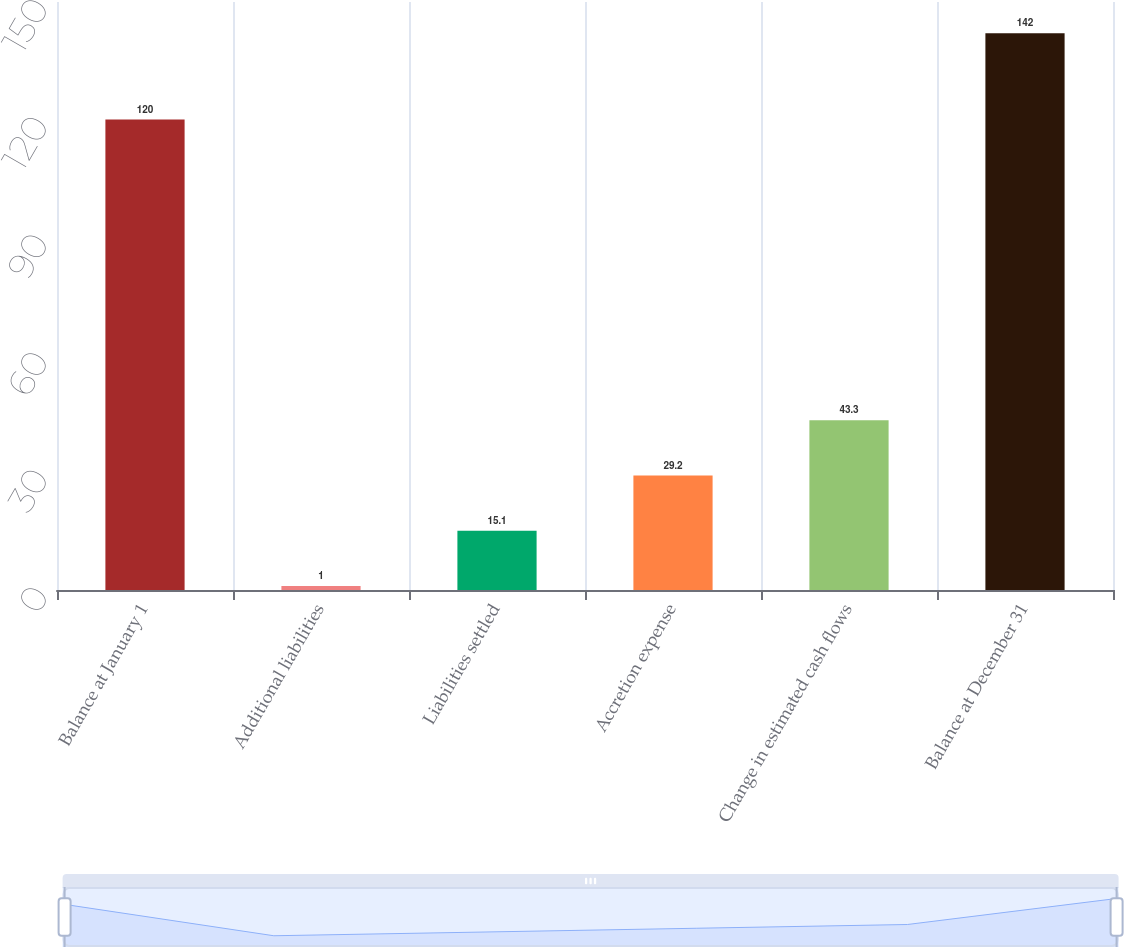Convert chart. <chart><loc_0><loc_0><loc_500><loc_500><bar_chart><fcel>Balance at January 1<fcel>Additional liabilities<fcel>Liabilities settled<fcel>Accretion expense<fcel>Change in estimated cash flows<fcel>Balance at December 31<nl><fcel>120<fcel>1<fcel>15.1<fcel>29.2<fcel>43.3<fcel>142<nl></chart> 